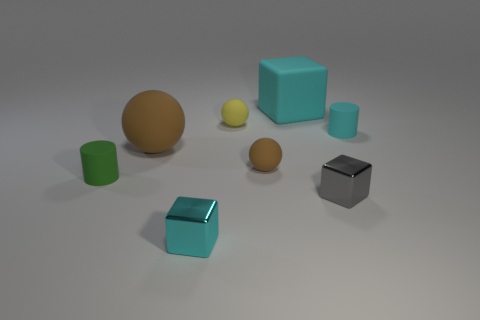Are there fewer brown rubber spheres than tiny yellow objects?
Offer a terse response. No. How many other tiny yellow objects have the same shape as the yellow rubber thing?
Ensure brevity in your answer.  0. There is another sphere that is the same size as the yellow sphere; what is its color?
Your answer should be compact. Brown. Is the number of small cyan matte cylinders to the left of the tiny green matte thing the same as the number of tiny rubber balls right of the cyan rubber block?
Offer a very short reply. Yes. Are there any yellow things that have the same size as the cyan rubber cylinder?
Your response must be concise. Yes. The gray block has what size?
Provide a short and direct response. Small. Is the number of large cyan matte things that are in front of the small gray thing the same as the number of blocks?
Offer a terse response. No. How many other things are the same color as the big matte sphere?
Your answer should be compact. 1. There is a rubber object that is both right of the green matte cylinder and on the left side of the small yellow ball; what is its color?
Provide a succinct answer. Brown. How big is the brown thing that is on the left side of the shiny thing to the left of the tiny block right of the cyan shiny thing?
Offer a terse response. Large. 